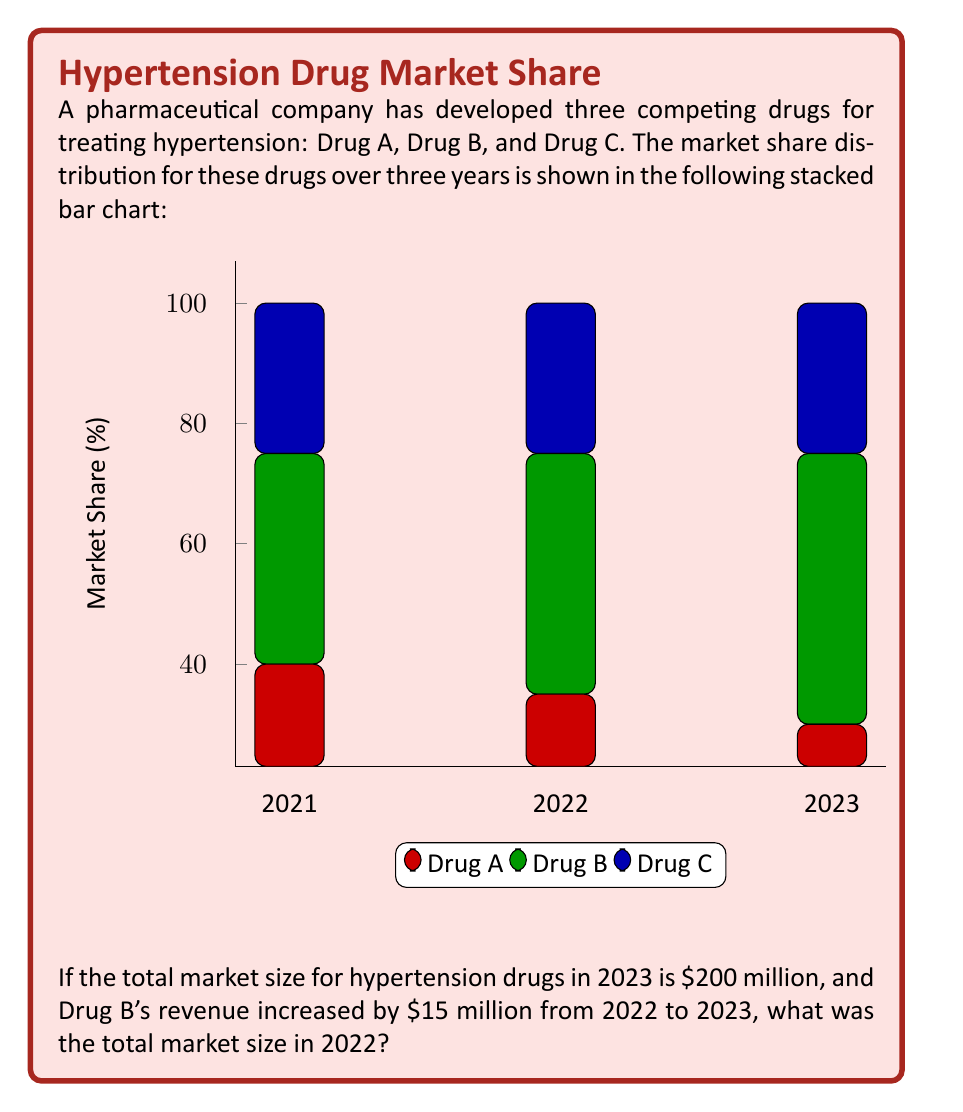Can you answer this question? Let's approach this step-by-step:

1) First, we need to identify Drug B's market share in 2022 and 2023:
   2022: 40%
   2023: 45%

2) We know the total market size in 2023 is $200 million. So, Drug B's revenue in 2023 was:
   $$200 \text{ million} \times 45\% = $90 \text{ million}$$

3) We're told that Drug B's revenue increased by $15 million from 2022 to 2023. So, Drug B's revenue in 2022 was:
   $$90 \text{ million} - 15 \text{ million} = $75 \text{ million}$$

4) Now, we know that in 2022, Drug B's $75 million revenue represented 40% of the total market. Let's call the total market size in 2022 $x$. We can set up this equation:
   $$75 \text{ million} = 40\% \times x$$
   $$75 \text{ million} = 0.4x$$

5) Solving for $x$:
   $$x = \frac{75 \text{ million}}{0.4} = 187.5 \text{ million}$$

Therefore, the total market size in 2022 was $187.5 million.
Answer: $187.5 million 